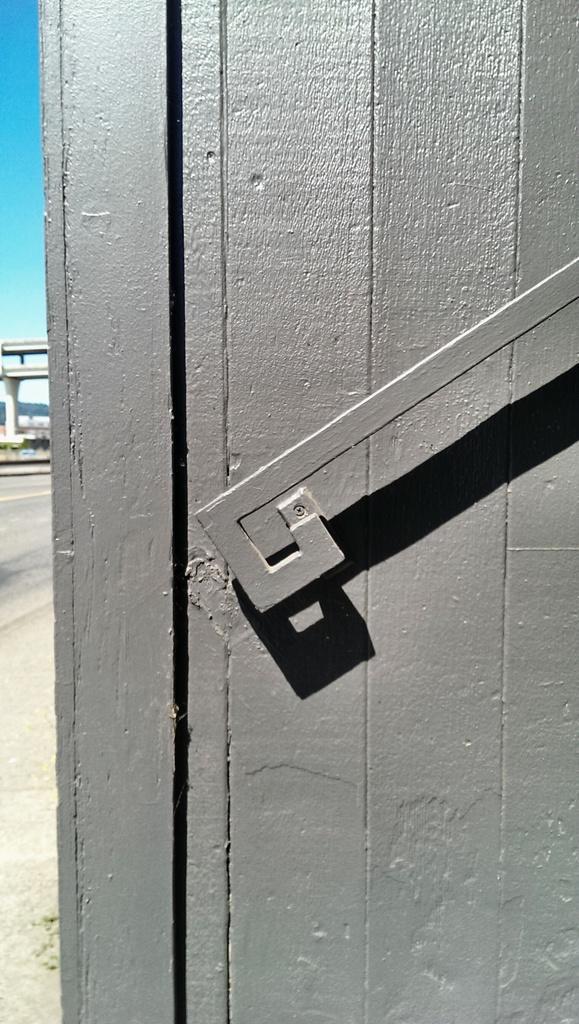Could you give a brief overview of what you see in this image? In this picture we can see a wooden wall in the front, on the left side we can see a bridge, there is the sky at the left top of the picture. 